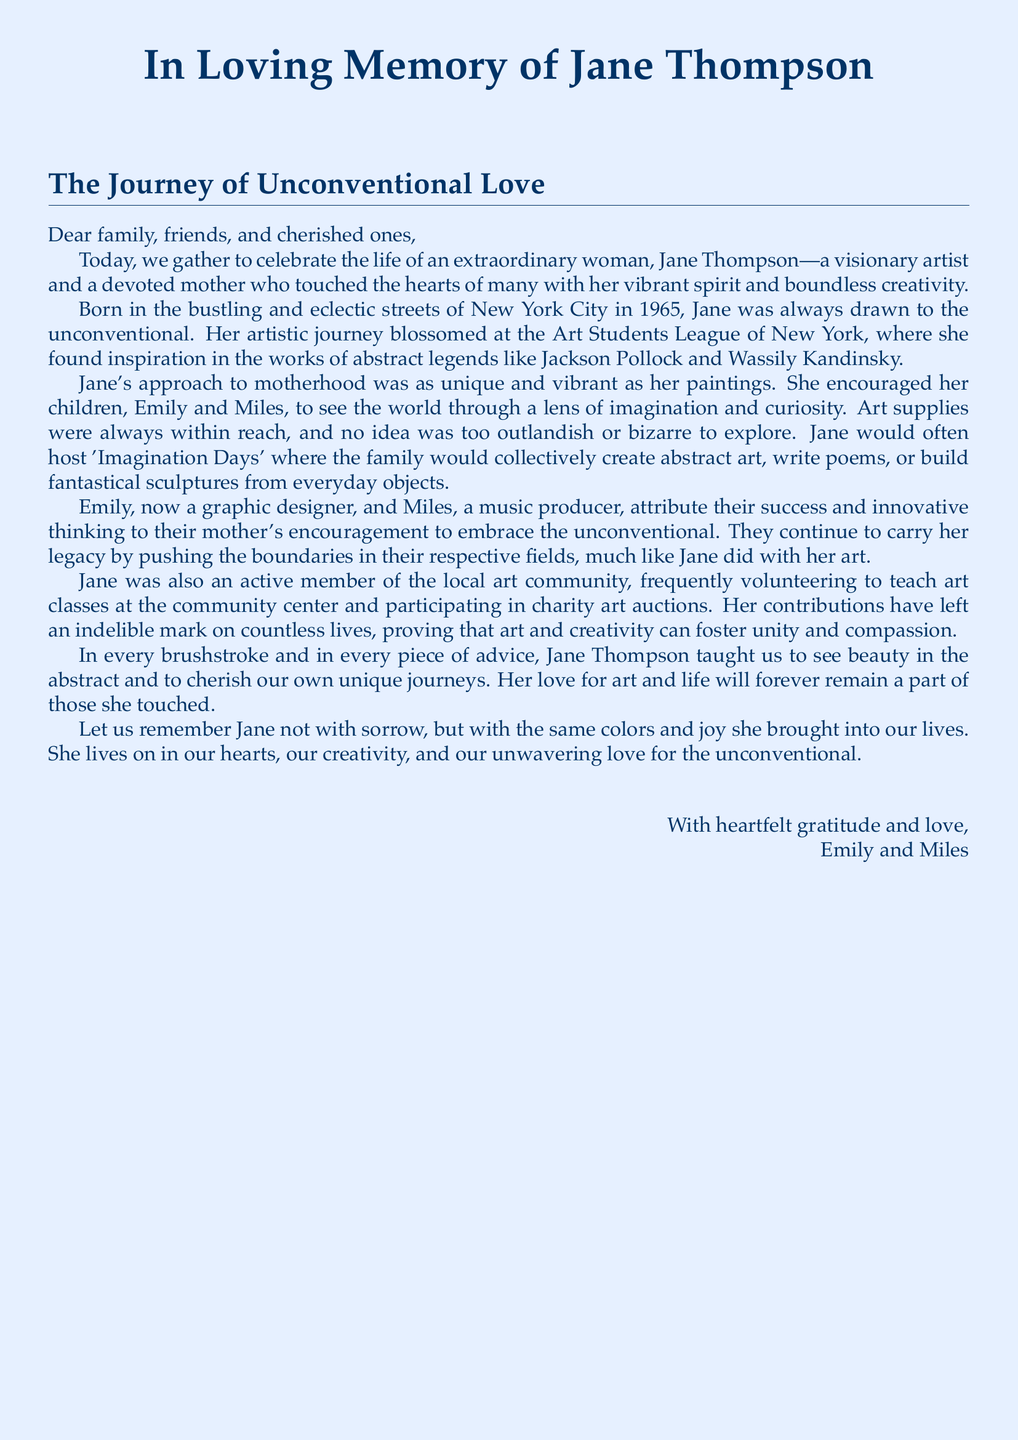What year was Jane Thompson born? The document states that Jane was born in 1965.
Answer: 1965 What were the names of Jane Thompson's children? The document mentions Emily and Miles as Jane's children.
Answer: Emily and Miles Which art movement inspired Jane's work? The document refers to her inspiration from abstract legends like Jackson Pollock and Wassily Kandinsky.
Answer: Abstract What type of events did Jane host for her family? The document describes 'Imagination Days' where the family created art together.
Answer: Imagination Days What professions do Emily and Miles have? The document states Emily is a graphic designer and Miles is a music producer.
Answer: Graphic designer and music producer What community activities did Jane participate in? The document mentions her volunteering to teach art classes and participating in charity art auctions.
Answer: Teaching and charity auctions What was Jane's approach to motherhood? The document describes her encouragement for her children to embrace imagination and curiosity.
Answer: Embrace imagination How do Emily and Miles continue Jane's legacy? The document indicates they push boundaries in their respective fields, reflecting their mother's influence.
Answer: Push boundaries 